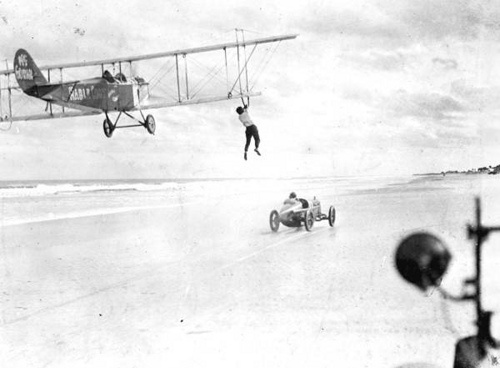Describe the objects in this image and their specific colors. I can see airplane in white, lightgray, darkgray, gray, and black tones, people in white, black, darkgray, gainsboro, and gray tones, and people in gray, darkgray, lightgray, and white tones in this image. 